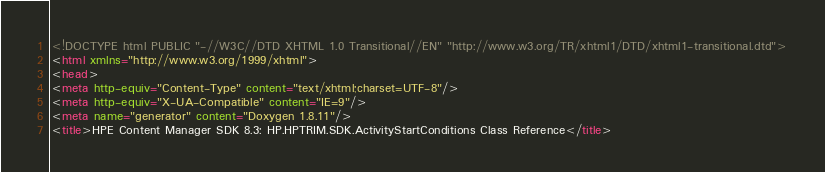Convert code to text. <code><loc_0><loc_0><loc_500><loc_500><_HTML_><!DOCTYPE html PUBLIC "-//W3C//DTD XHTML 1.0 Transitional//EN" "http://www.w3.org/TR/xhtml1/DTD/xhtml1-transitional.dtd">
<html xmlns="http://www.w3.org/1999/xhtml">
<head>
<meta http-equiv="Content-Type" content="text/xhtml;charset=UTF-8"/>
<meta http-equiv="X-UA-Compatible" content="IE=9"/>
<meta name="generator" content="Doxygen 1.8.11"/>
<title>HPE Content Manager SDK 8.3: HP.HPTRIM.SDK.ActivityStartConditions Class Reference</title></code> 